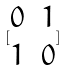Convert formula to latex. <formula><loc_0><loc_0><loc_500><loc_500>[ \begin{matrix} 0 & 1 \\ 1 & 0 \end{matrix} ]</formula> 